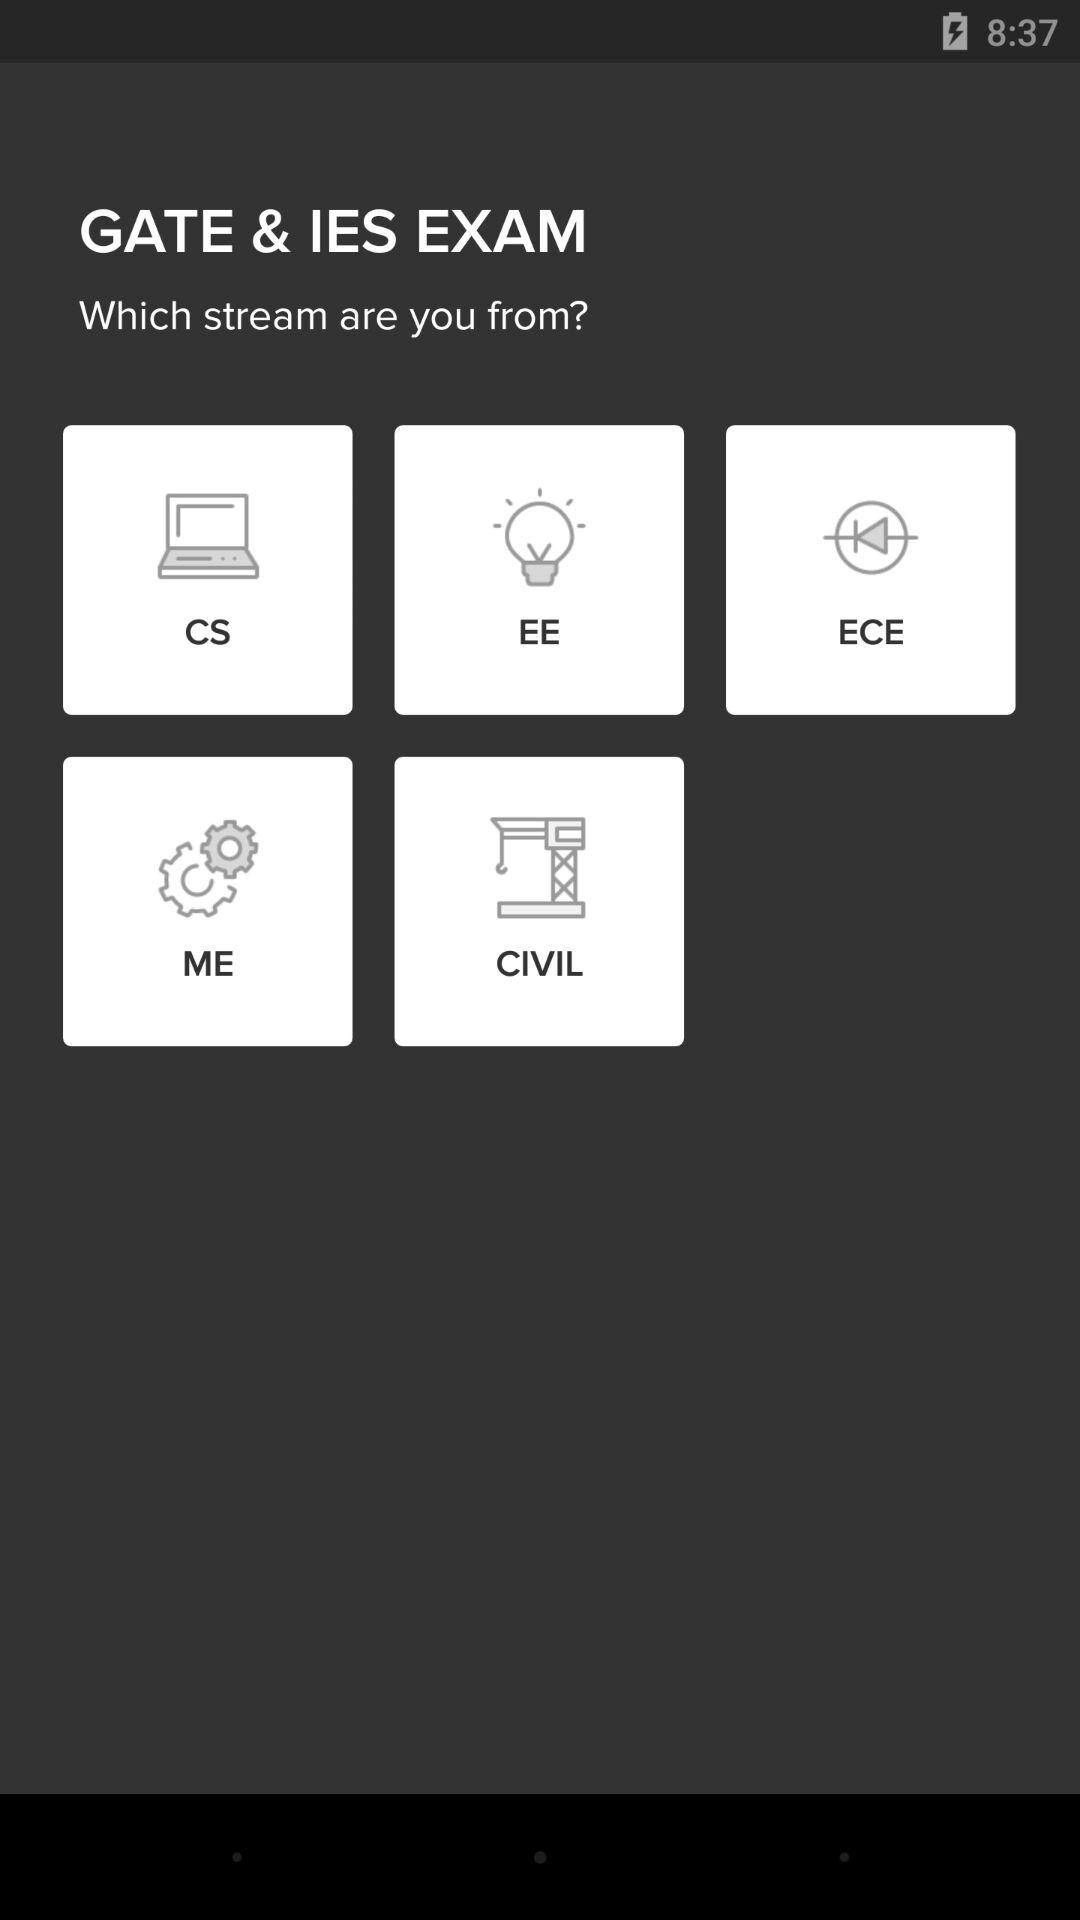What is the name of the exam? The name of the exam is GATE & IES. 